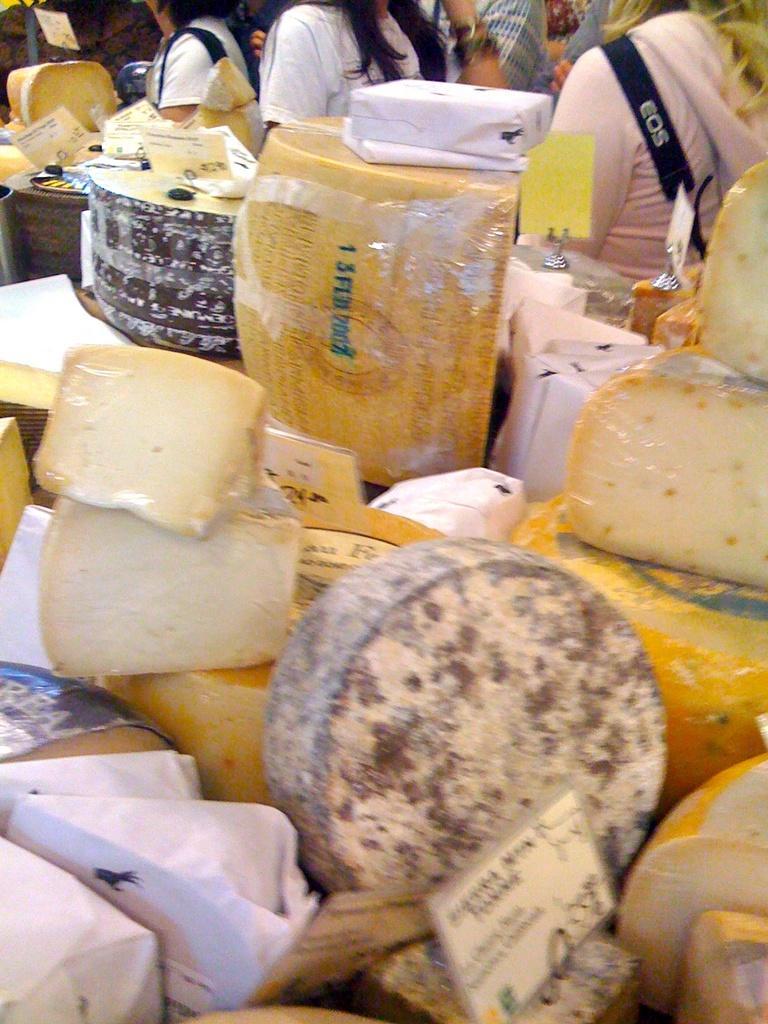Describe this image in one or two sentences. In this image, we can see some food items. We can see some boards with text written. There are a few people. We can also see a white colored object. 